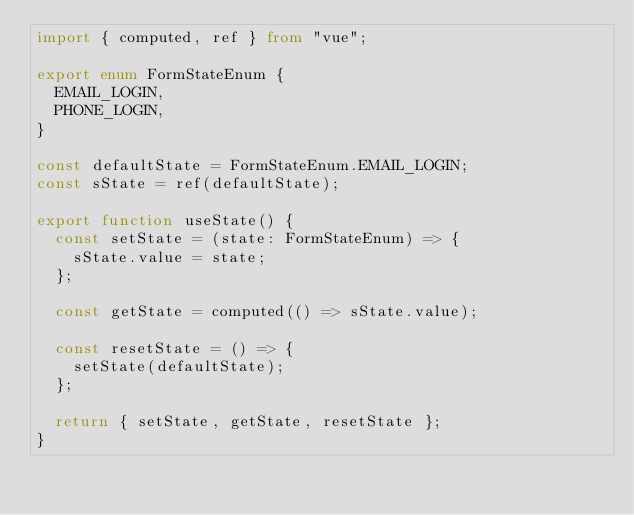<code> <loc_0><loc_0><loc_500><loc_500><_TypeScript_>import { computed, ref } from "vue";

export enum FormStateEnum {
  EMAIL_LOGIN,
  PHONE_LOGIN,
}

const defaultState = FormStateEnum.EMAIL_LOGIN;
const sState = ref(defaultState);

export function useState() {
  const setState = (state: FormStateEnum) => {
    sState.value = state;
  };

  const getState = computed(() => sState.value);

  const resetState = () => {
    setState(defaultState);
  };

  return { setState, getState, resetState };
}
</code> 